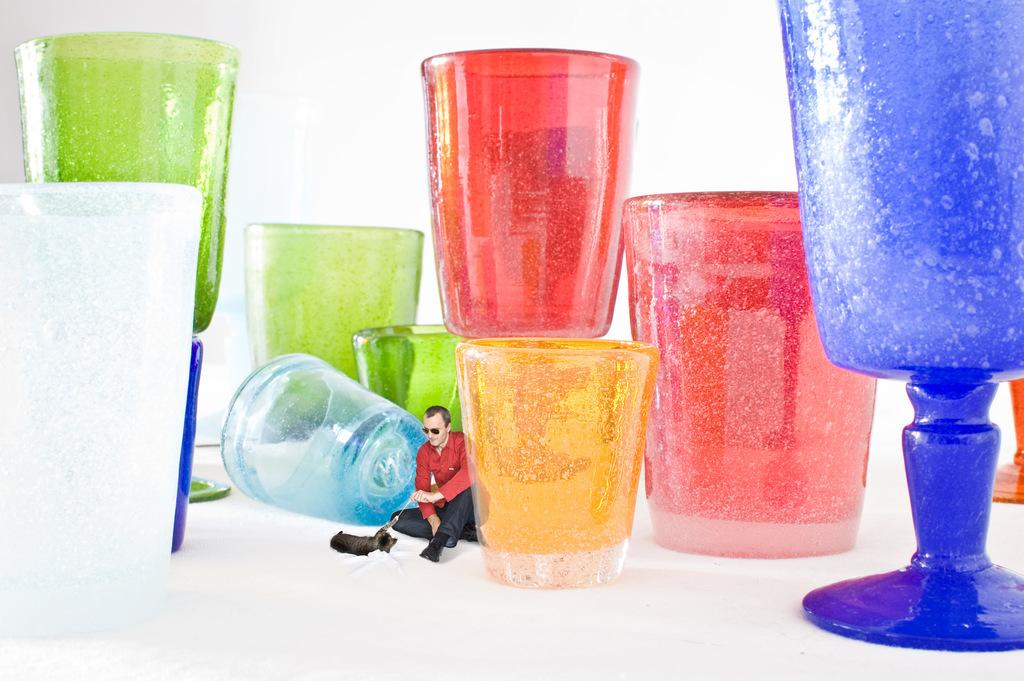What objects are present in the image in large quantities? There are many glasses in the image. How do the glasses differ from one another? The glasses are of different colors. Who is present in the image? There is a man in the image. What is the man doing in the image? The man is sitting. What is the man wearing in the image? The man is wearing a red shirt. What type of fowl can be seen walking on the floor in the image? There is no fowl present in the image, and the floor is not visible. What mark can be seen on the man's shirt in the image? There is no mark visible on the man's red shirt in the image. 